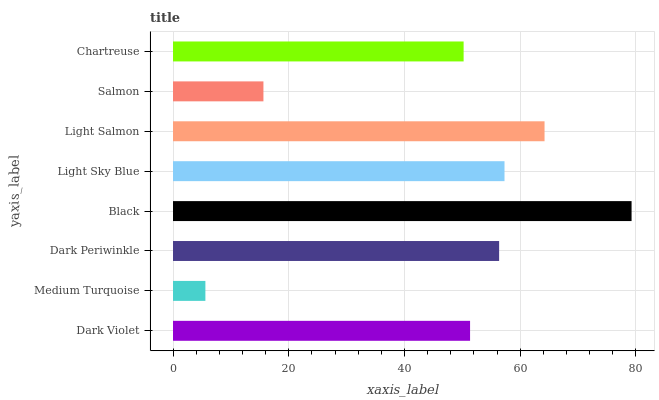Is Medium Turquoise the minimum?
Answer yes or no. Yes. Is Black the maximum?
Answer yes or no. Yes. Is Dark Periwinkle the minimum?
Answer yes or no. No. Is Dark Periwinkle the maximum?
Answer yes or no. No. Is Dark Periwinkle greater than Medium Turquoise?
Answer yes or no. Yes. Is Medium Turquoise less than Dark Periwinkle?
Answer yes or no. Yes. Is Medium Turquoise greater than Dark Periwinkle?
Answer yes or no. No. Is Dark Periwinkle less than Medium Turquoise?
Answer yes or no. No. Is Dark Periwinkle the high median?
Answer yes or no. Yes. Is Dark Violet the low median?
Answer yes or no. Yes. Is Chartreuse the high median?
Answer yes or no. No. Is Light Sky Blue the low median?
Answer yes or no. No. 